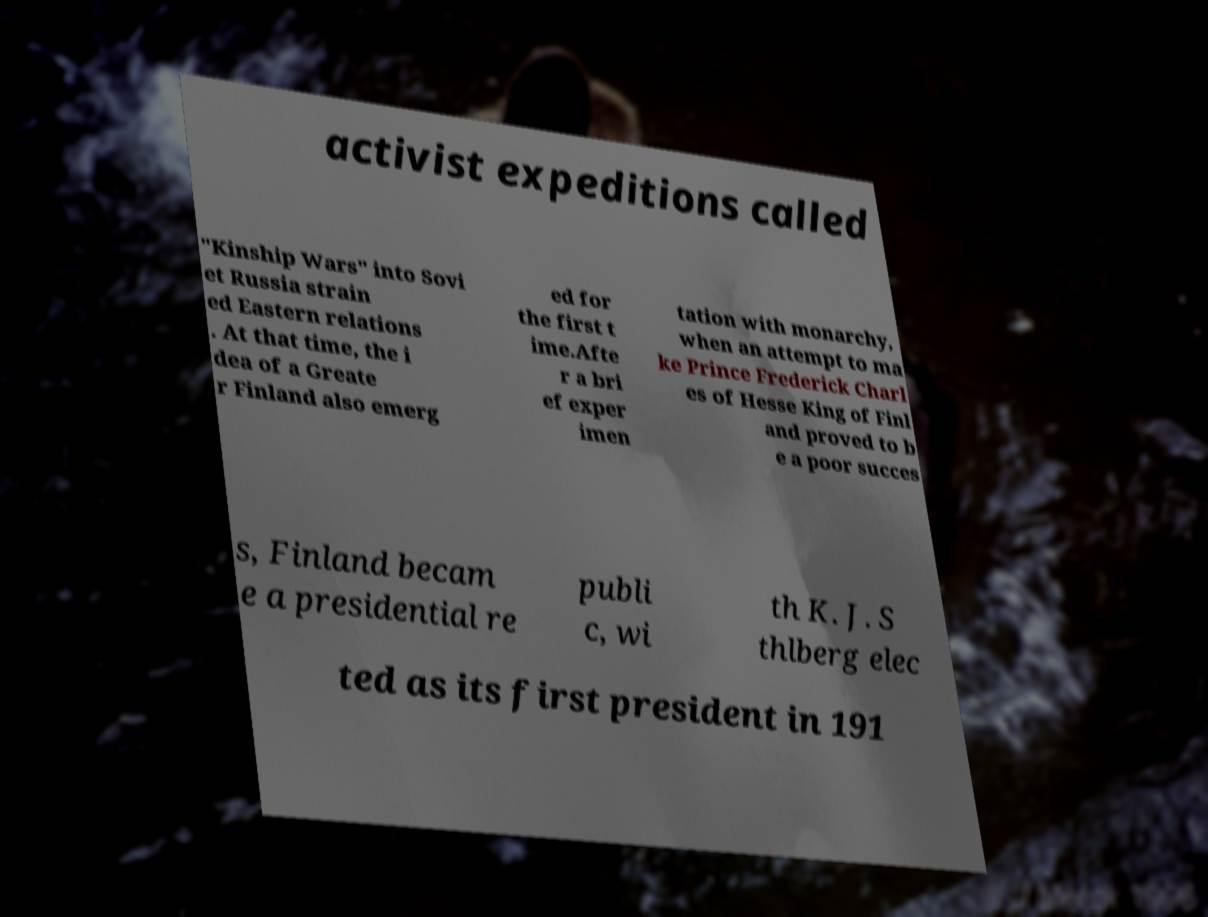Please identify and transcribe the text found in this image. activist expeditions called "Kinship Wars" into Sovi et Russia strain ed Eastern relations . At that time, the i dea of a Greate r Finland also emerg ed for the first t ime.Afte r a bri ef exper imen tation with monarchy, when an attempt to ma ke Prince Frederick Charl es of Hesse King of Finl and proved to b e a poor succes s, Finland becam e a presidential re publi c, wi th K. J. S thlberg elec ted as its first president in 191 